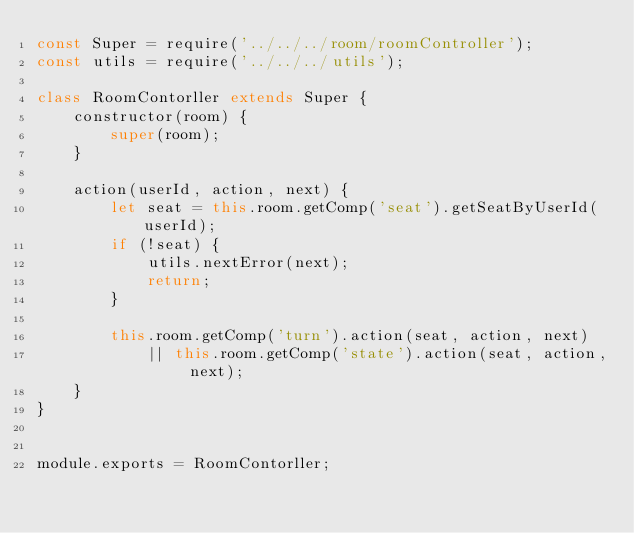Convert code to text. <code><loc_0><loc_0><loc_500><loc_500><_JavaScript_>const Super = require('../../../room/roomController');
const utils = require('../../../utils');

class RoomContorller extends Super {
    constructor(room) {
        super(room);
    }

    action(userId, action, next) {
        let seat = this.room.getComp('seat').getSeatByUserId(userId);
        if (!seat) {
            utils.nextError(next);
            return;
        }

        this.room.getComp('turn').action(seat, action, next)
            || this.room.getComp('state').action(seat, action, next);
    }
}


module.exports = RoomContorller;
</code> 